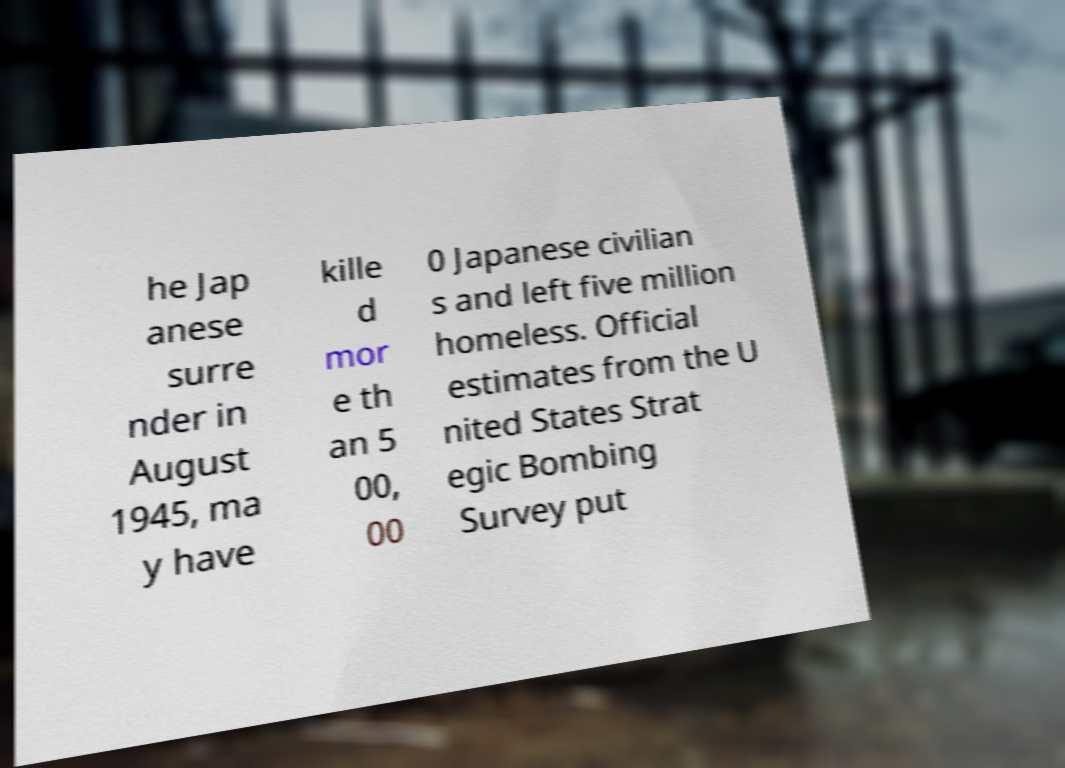Can you read and provide the text displayed in the image?This photo seems to have some interesting text. Can you extract and type it out for me? he Jap anese surre nder in August 1945, ma y have kille d mor e th an 5 00, 00 0 Japanese civilian s and left five million homeless. Official estimates from the U nited States Strat egic Bombing Survey put 